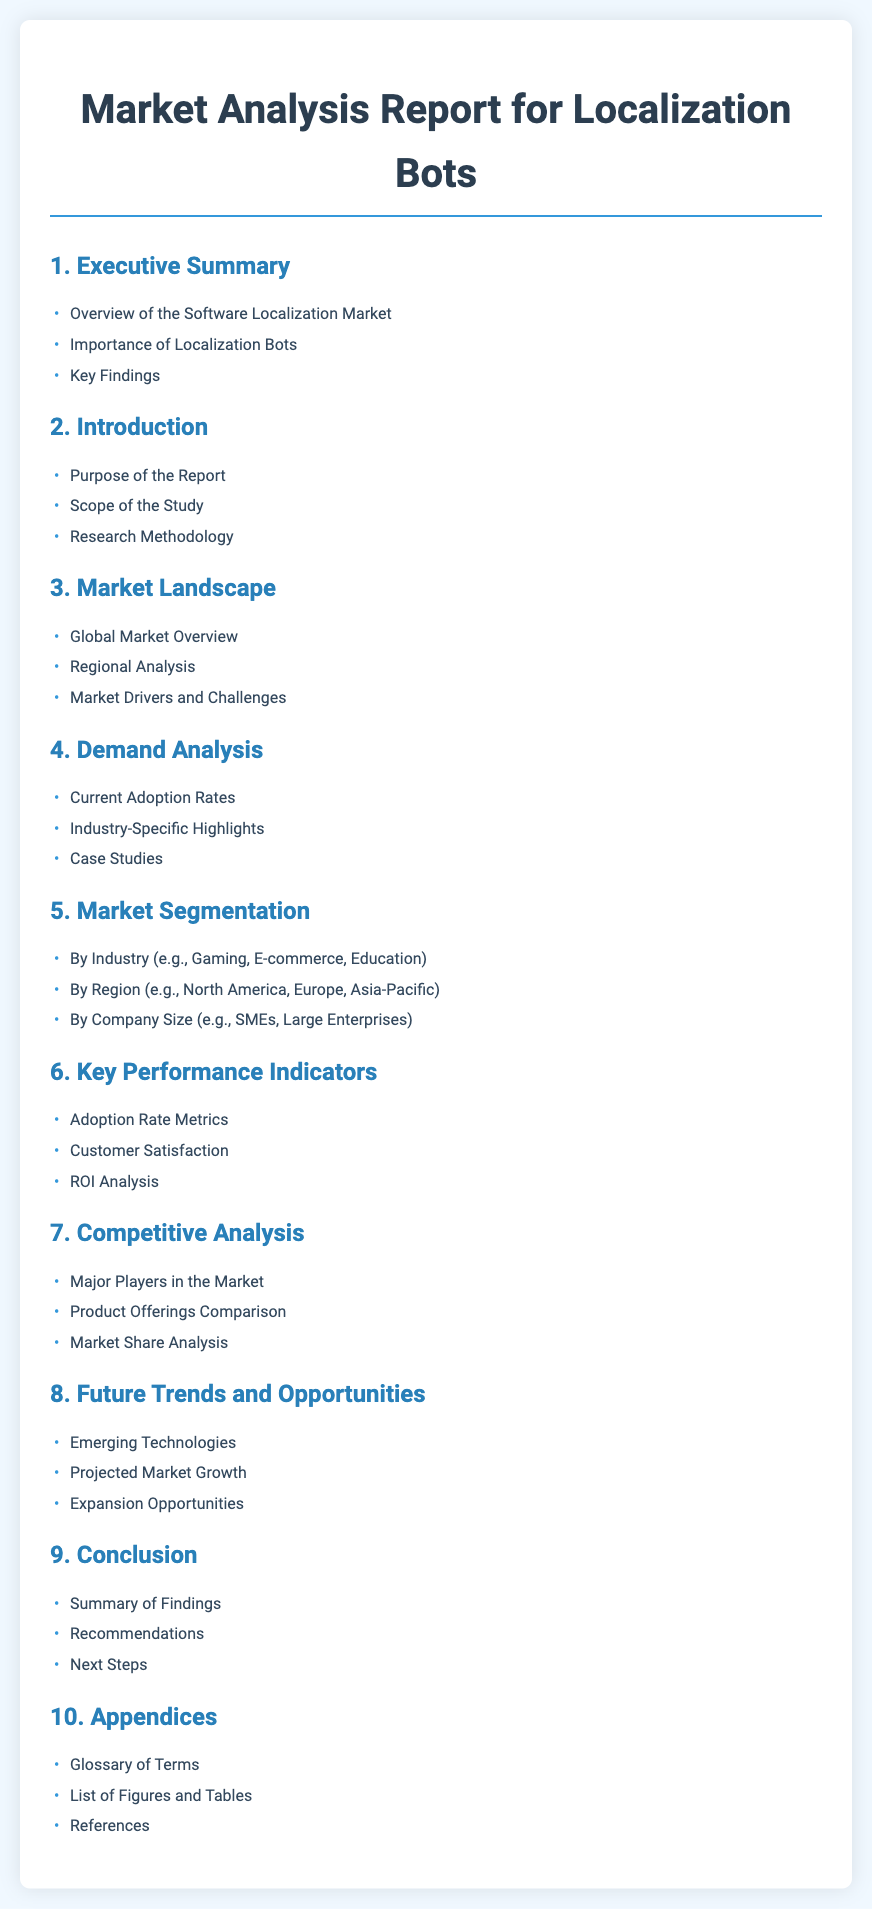What is the title of the report? The title of the report is located in the header of the document.
Answer: Market Analysis Report for Localization Bots How many main sections are there in the Table of Contents? The number of main sections can be counted from the list provided in the Table of Contents.
Answer: 10 What is the first item under the Executive Summary? The first item can be found in the dropdown list under the Executive Summary section.
Answer: Overview of the Software Localization Market What topics are covered under the Market Segmentation? The topics can be found as bullet points under the Market Segmentation section.
Answer: By Industry, By Region, By Company Size Which section discusses Emerging Technologies? The section that discusses this topic can be identified in the Table of Contents.
Answer: Future Trends and Opportunities What are the three items listed under the Conclusion section? This information is available as bullet points in the Conclusion section.
Answer: Summary of Findings, Recommendations, Next Steps Which region is mentioned specifically in the Market Segmentation? The specific region can be found as part of the bullet points in the Market Segmentation section.
Answer: Asia-Pacific What key performance indicator is included in the Key Performance Indicators section? This information can be determined by looking at the list in the Key Performance Indicators section.
Answer: Customer Satisfaction Who is the audience for the report based on the Purpose of the Report? The intended audience is typically summarized in the Purpose of the Report section.
Answer: Stakeholders What type of analysis is included in the Competitive Analysis section? The type of analysis can be identified from the bullet points in the Competitive Analysis section.
Answer: Market Share Analysis 